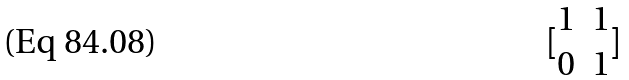<formula> <loc_0><loc_0><loc_500><loc_500>[ \begin{matrix} 1 & 1 \\ 0 & 1 \end{matrix} ]</formula> 